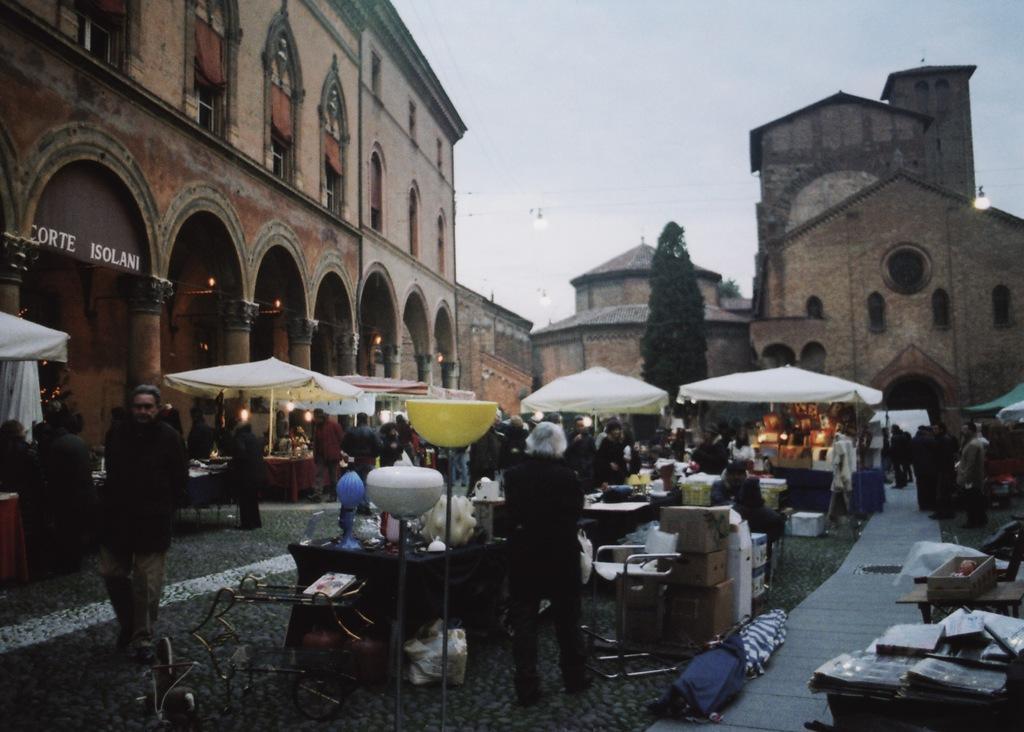Please provide a concise description of this image. The image is outside of the city. In the image there are group of people standing and walking and we can also see some stalls on right side and left side, in background there are buildings,trees and sky is on top. 